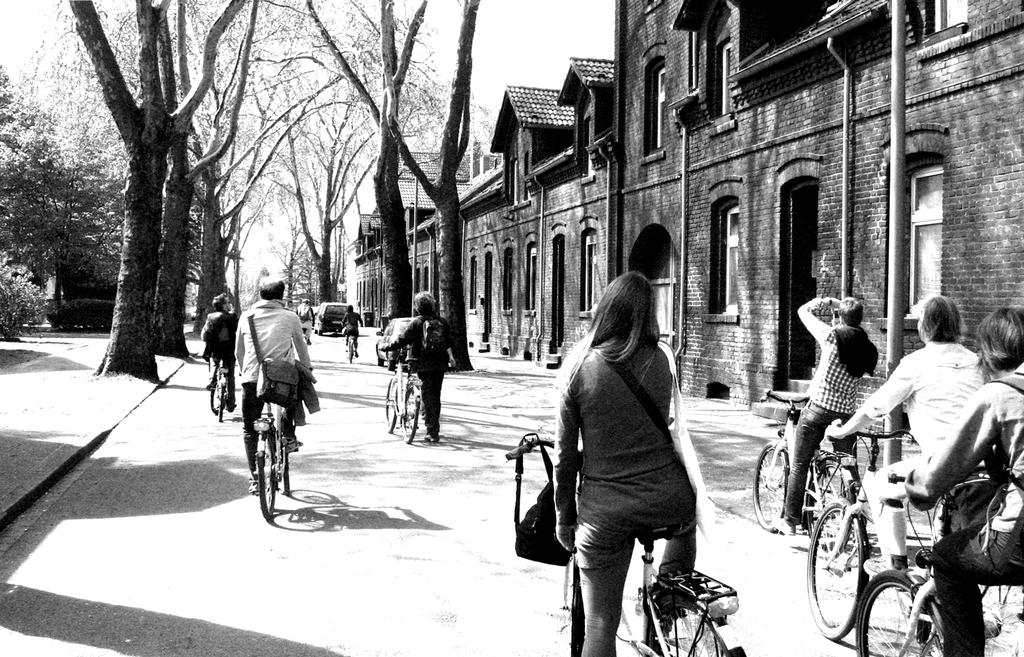What are the people in the image doing? The people in the image are riding bicycles on a road. Can you describe the woman in the image? The woman is standing on a bicycle. What is located beside the road? There is a building and trees beside the road. What can be seen in the sky in the image? The sky is visible in the image. How many clocks are hanging from the trees in the image? There are no clocks hanging from the trees in the image. Can you describe the feather on the woman's bicycle in the image? There is no feather present on the woman's bicycle in the image. 